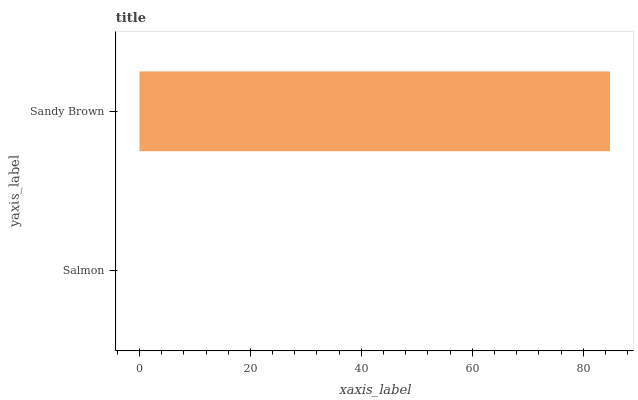Is Salmon the minimum?
Answer yes or no. Yes. Is Sandy Brown the maximum?
Answer yes or no. Yes. Is Sandy Brown the minimum?
Answer yes or no. No. Is Sandy Brown greater than Salmon?
Answer yes or no. Yes. Is Salmon less than Sandy Brown?
Answer yes or no. Yes. Is Salmon greater than Sandy Brown?
Answer yes or no. No. Is Sandy Brown less than Salmon?
Answer yes or no. No. Is Sandy Brown the high median?
Answer yes or no. Yes. Is Salmon the low median?
Answer yes or no. Yes. Is Salmon the high median?
Answer yes or no. No. Is Sandy Brown the low median?
Answer yes or no. No. 